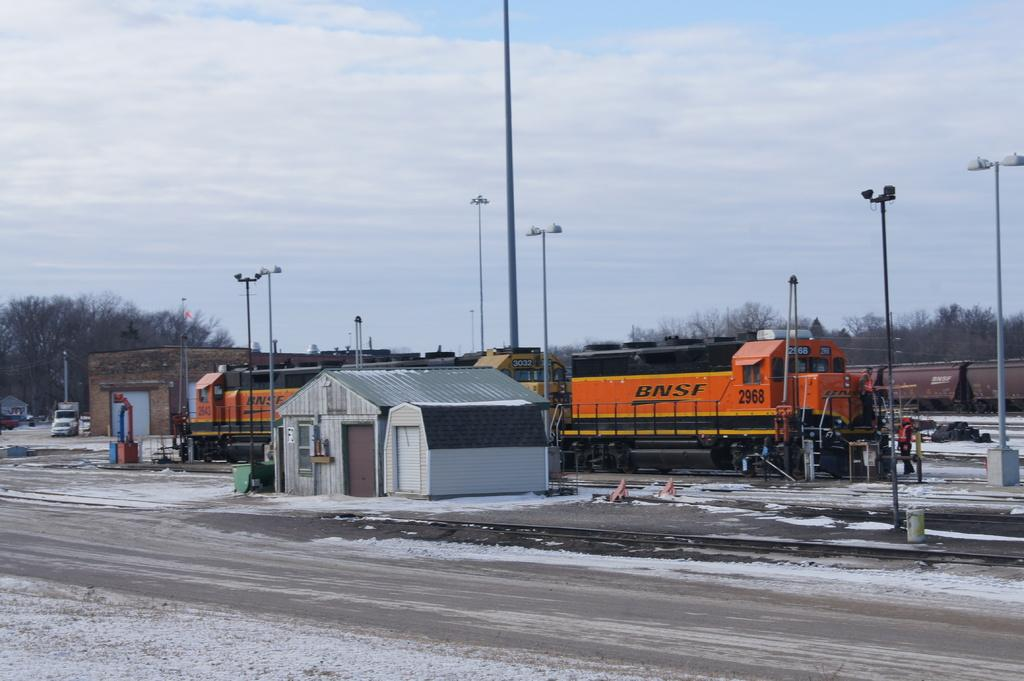Provide a one-sentence caption for the provided image. An small, orange BNSF train passes through a station. 